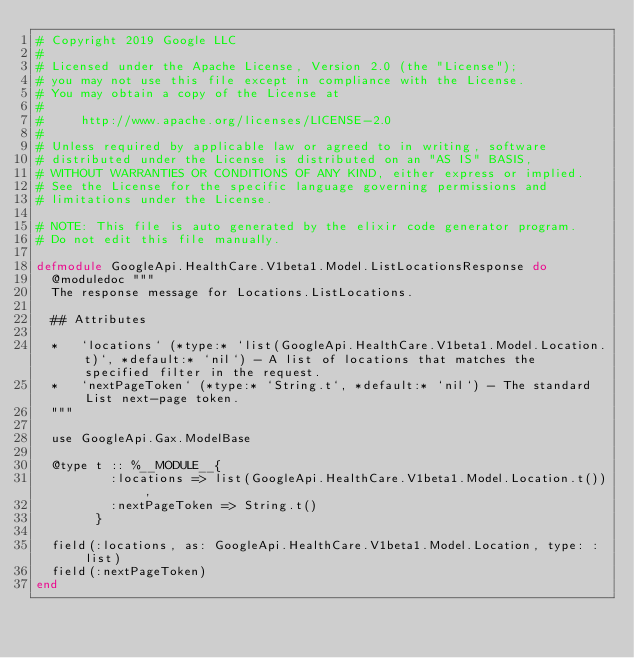<code> <loc_0><loc_0><loc_500><loc_500><_Elixir_># Copyright 2019 Google LLC
#
# Licensed under the Apache License, Version 2.0 (the "License");
# you may not use this file except in compliance with the License.
# You may obtain a copy of the License at
#
#     http://www.apache.org/licenses/LICENSE-2.0
#
# Unless required by applicable law or agreed to in writing, software
# distributed under the License is distributed on an "AS IS" BASIS,
# WITHOUT WARRANTIES OR CONDITIONS OF ANY KIND, either express or implied.
# See the License for the specific language governing permissions and
# limitations under the License.

# NOTE: This file is auto generated by the elixir code generator program.
# Do not edit this file manually.

defmodule GoogleApi.HealthCare.V1beta1.Model.ListLocationsResponse do
  @moduledoc """
  The response message for Locations.ListLocations.

  ## Attributes

  *   `locations` (*type:* `list(GoogleApi.HealthCare.V1beta1.Model.Location.t)`, *default:* `nil`) - A list of locations that matches the specified filter in the request.
  *   `nextPageToken` (*type:* `String.t`, *default:* `nil`) - The standard List next-page token.
  """

  use GoogleApi.Gax.ModelBase

  @type t :: %__MODULE__{
          :locations => list(GoogleApi.HealthCare.V1beta1.Model.Location.t()),
          :nextPageToken => String.t()
        }

  field(:locations, as: GoogleApi.HealthCare.V1beta1.Model.Location, type: :list)
  field(:nextPageToken)
end
</code> 